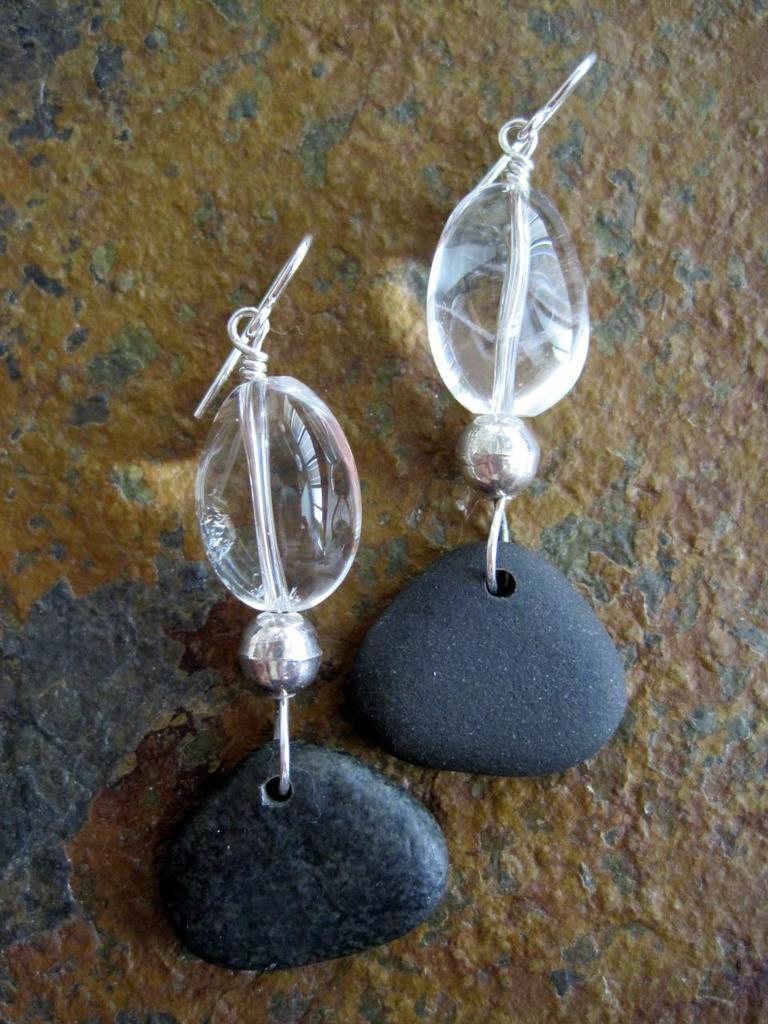In one or two sentences, can you explain what this image depicts? In this picture we can see earrings on the surface. 